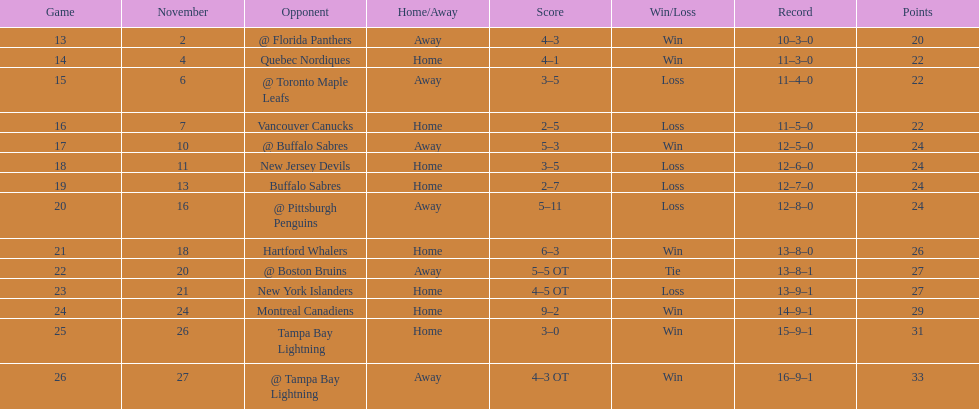What was the number of wins the philadelphia flyers had? 35. 